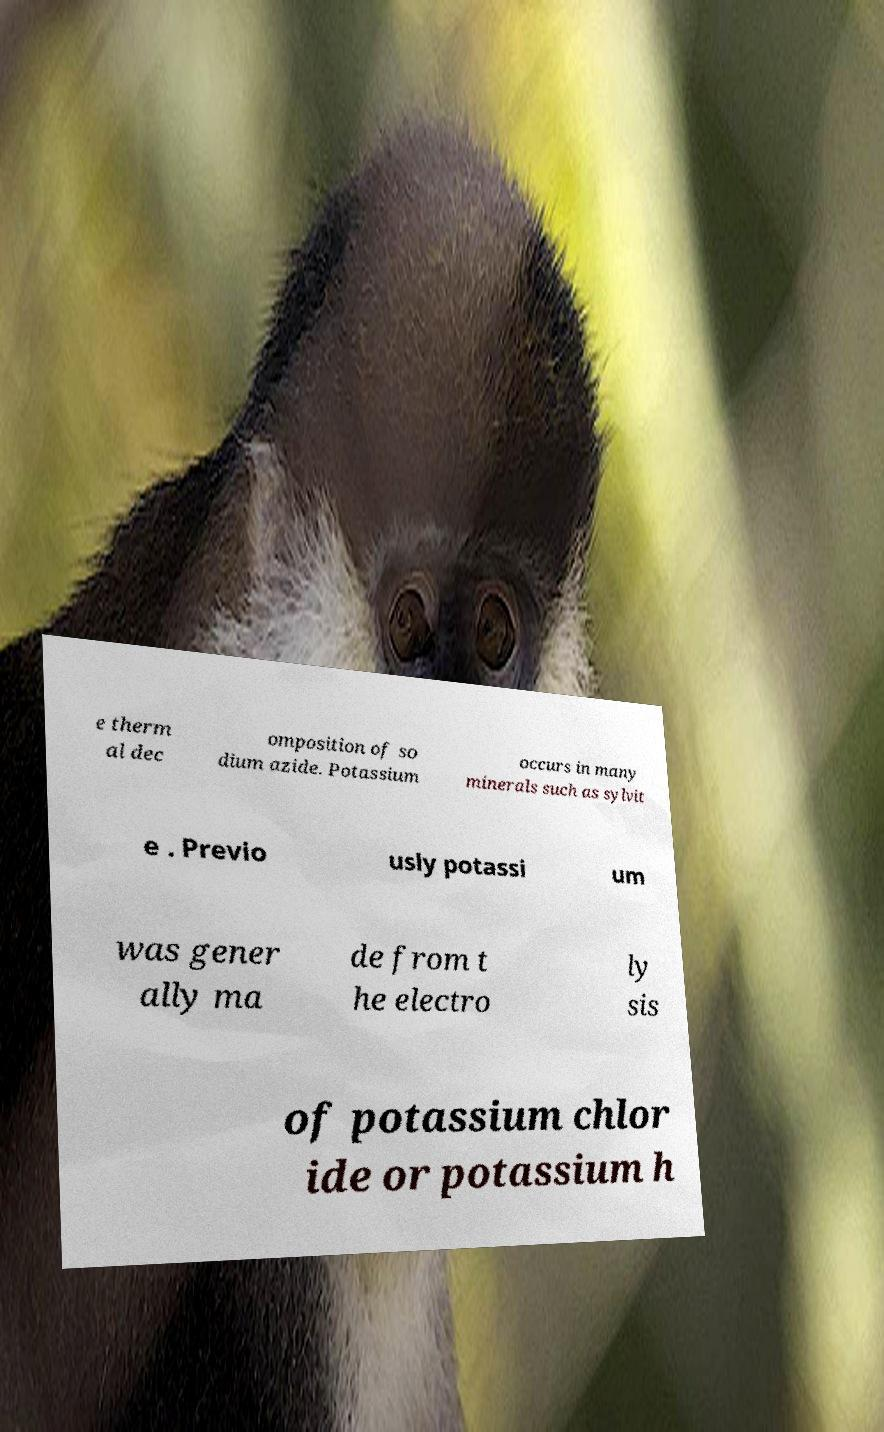Can you read and provide the text displayed in the image?This photo seems to have some interesting text. Can you extract and type it out for me? e therm al dec omposition of so dium azide. Potassium occurs in many minerals such as sylvit e . Previo usly potassi um was gener ally ma de from t he electro ly sis of potassium chlor ide or potassium h 